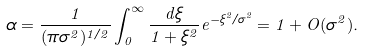<formula> <loc_0><loc_0><loc_500><loc_500>\alpha = \frac { 1 } { ( \pi \sigma ^ { 2 } ) ^ { 1 / 2 } } \int _ { 0 } ^ { \infty } \frac { d \xi } { 1 + \xi ^ { 2 } } e ^ { - \xi ^ { 2 } / \sigma ^ { 2 } } = 1 + O ( \sigma ^ { 2 } ) .</formula> 